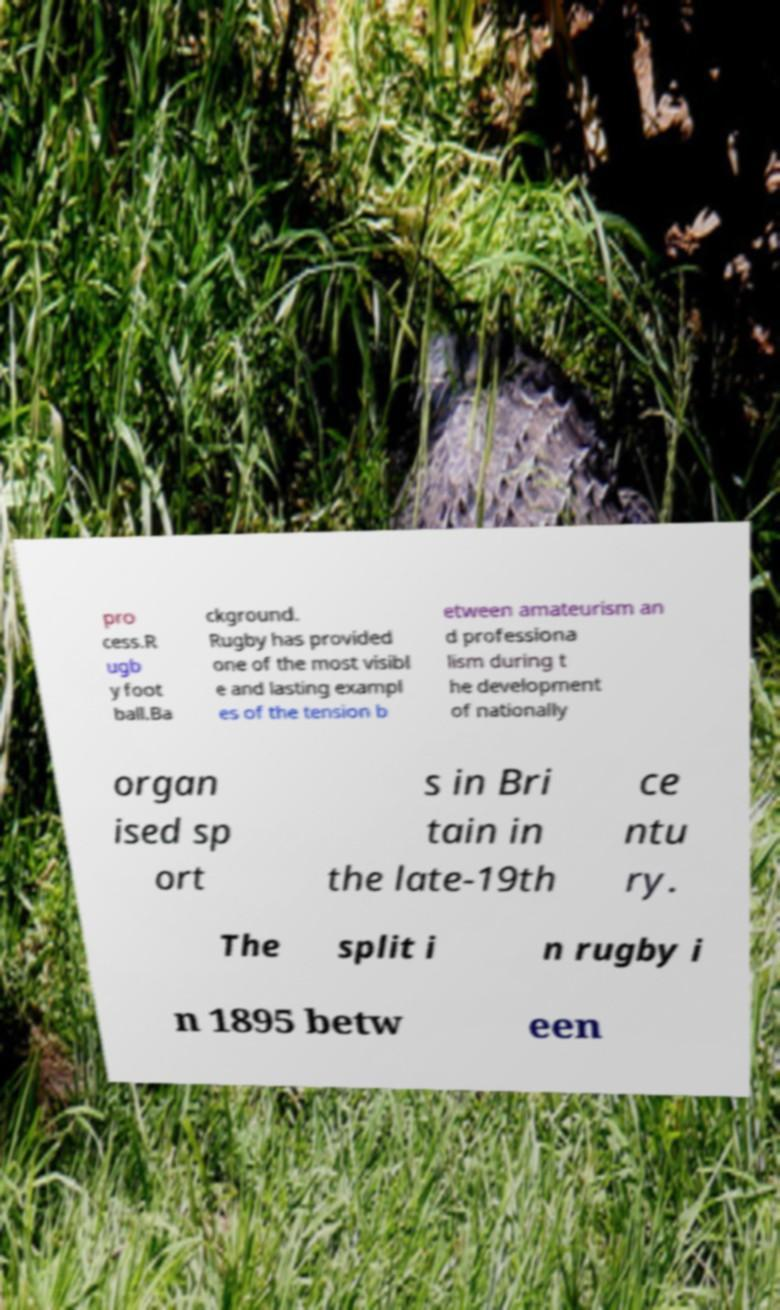Can you read and provide the text displayed in the image?This photo seems to have some interesting text. Can you extract and type it out for me? pro cess.R ugb y foot ball.Ba ckground. Rugby has provided one of the most visibl e and lasting exampl es of the tension b etween amateurism an d professiona lism during t he development of nationally organ ised sp ort s in Bri tain in the late-19th ce ntu ry. The split i n rugby i n 1895 betw een 